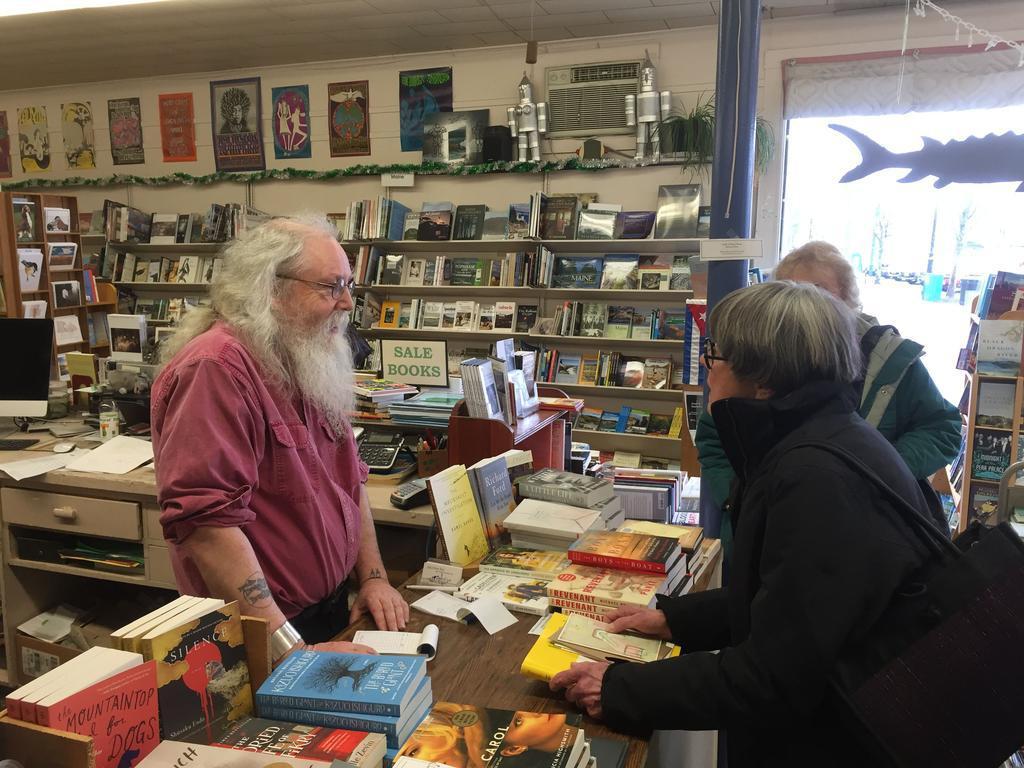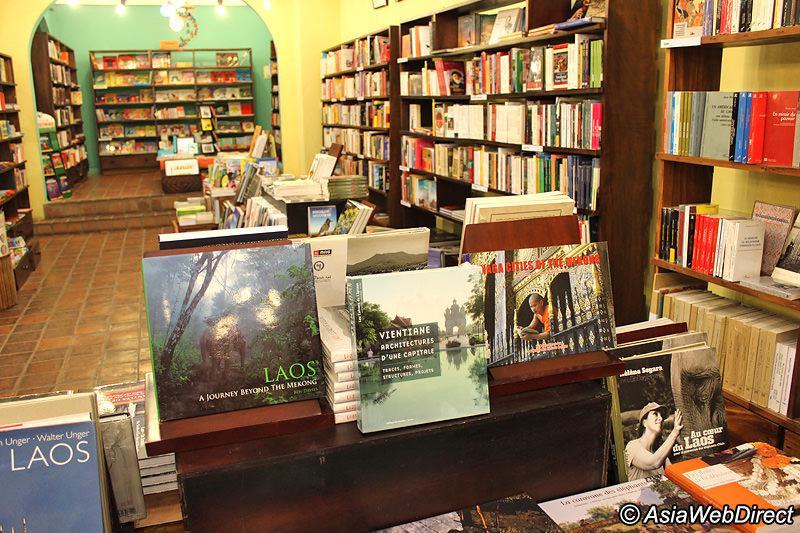The first image is the image on the left, the second image is the image on the right. Evaluate the accuracy of this statement regarding the images: "In one image there is a man with a beard in a bookstore.". Is it true? Answer yes or no. Yes. The first image is the image on the left, the second image is the image on the right. Given the left and right images, does the statement "A man with a gray beard and glasses stands behind a counter stacked with books in one image, and the other image shows a display with a book's front cover." hold true? Answer yes or no. Yes. 